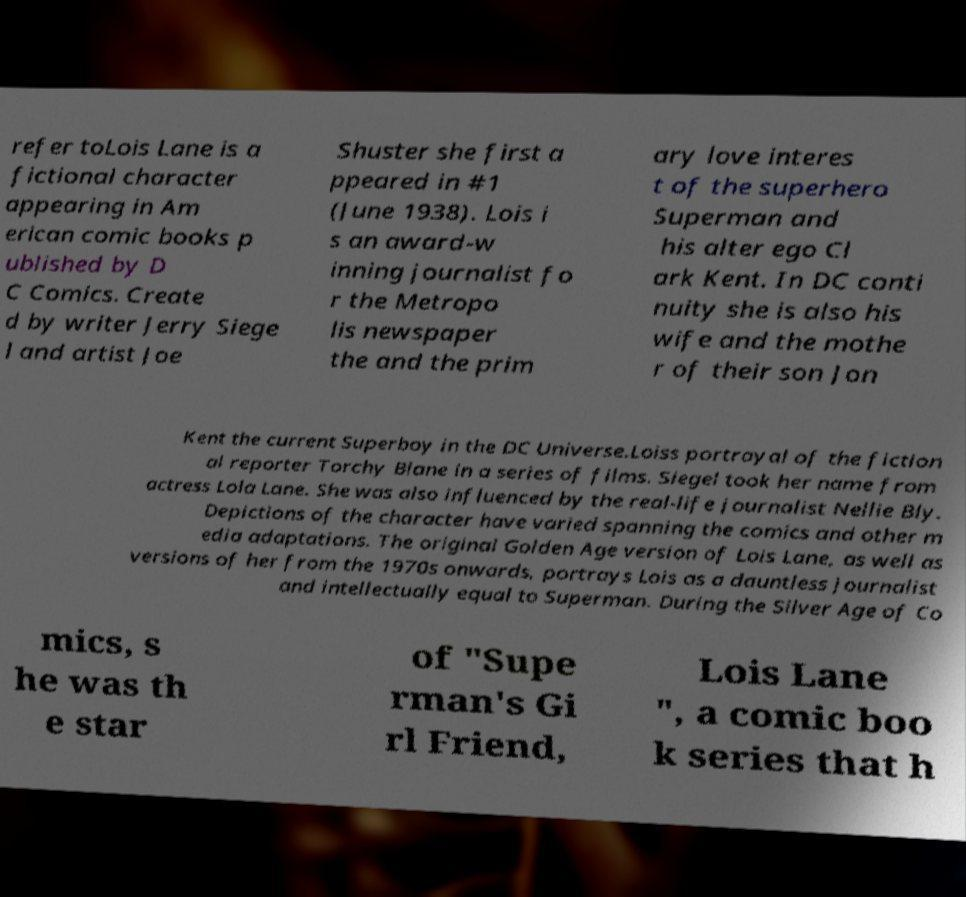Please identify and transcribe the text found in this image. refer toLois Lane is a fictional character appearing in Am erican comic books p ublished by D C Comics. Create d by writer Jerry Siege l and artist Joe Shuster she first a ppeared in #1 (June 1938). Lois i s an award-w inning journalist fo r the Metropo lis newspaper the and the prim ary love interes t of the superhero Superman and his alter ego Cl ark Kent. In DC conti nuity she is also his wife and the mothe r of their son Jon Kent the current Superboy in the DC Universe.Loiss portrayal of the fiction al reporter Torchy Blane in a series of films. Siegel took her name from actress Lola Lane. She was also influenced by the real-life journalist Nellie Bly. Depictions of the character have varied spanning the comics and other m edia adaptations. The original Golden Age version of Lois Lane, as well as versions of her from the 1970s onwards, portrays Lois as a dauntless journalist and intellectually equal to Superman. During the Silver Age of Co mics, s he was th e star of "Supe rman's Gi rl Friend, Lois Lane ", a comic boo k series that h 